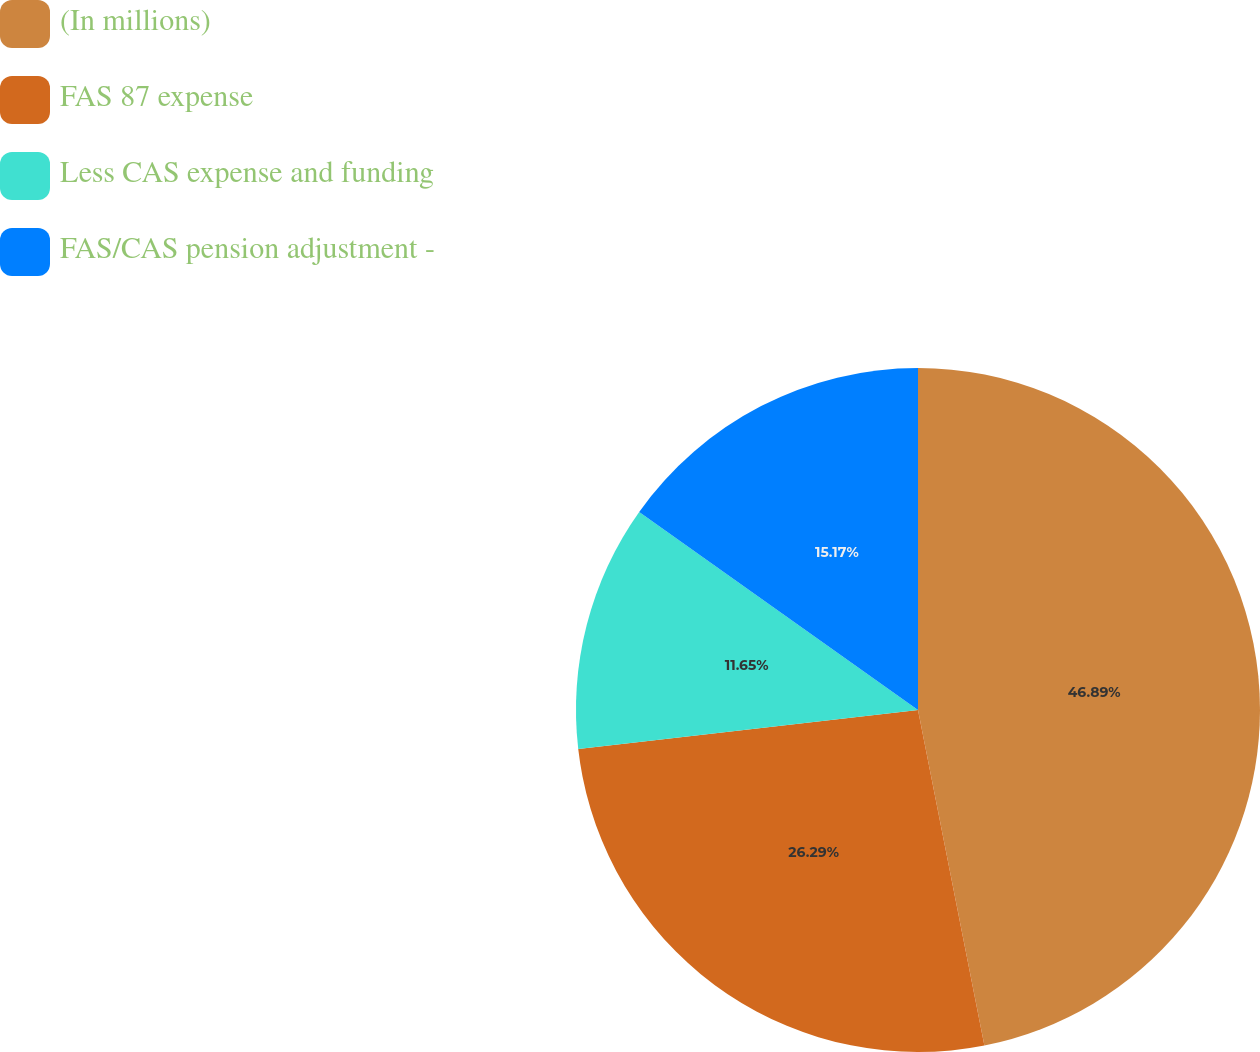<chart> <loc_0><loc_0><loc_500><loc_500><pie_chart><fcel>(In millions)<fcel>FAS 87 expense<fcel>Less CAS expense and funding<fcel>FAS/CAS pension adjustment -<nl><fcel>46.89%<fcel>26.29%<fcel>11.65%<fcel>15.17%<nl></chart> 